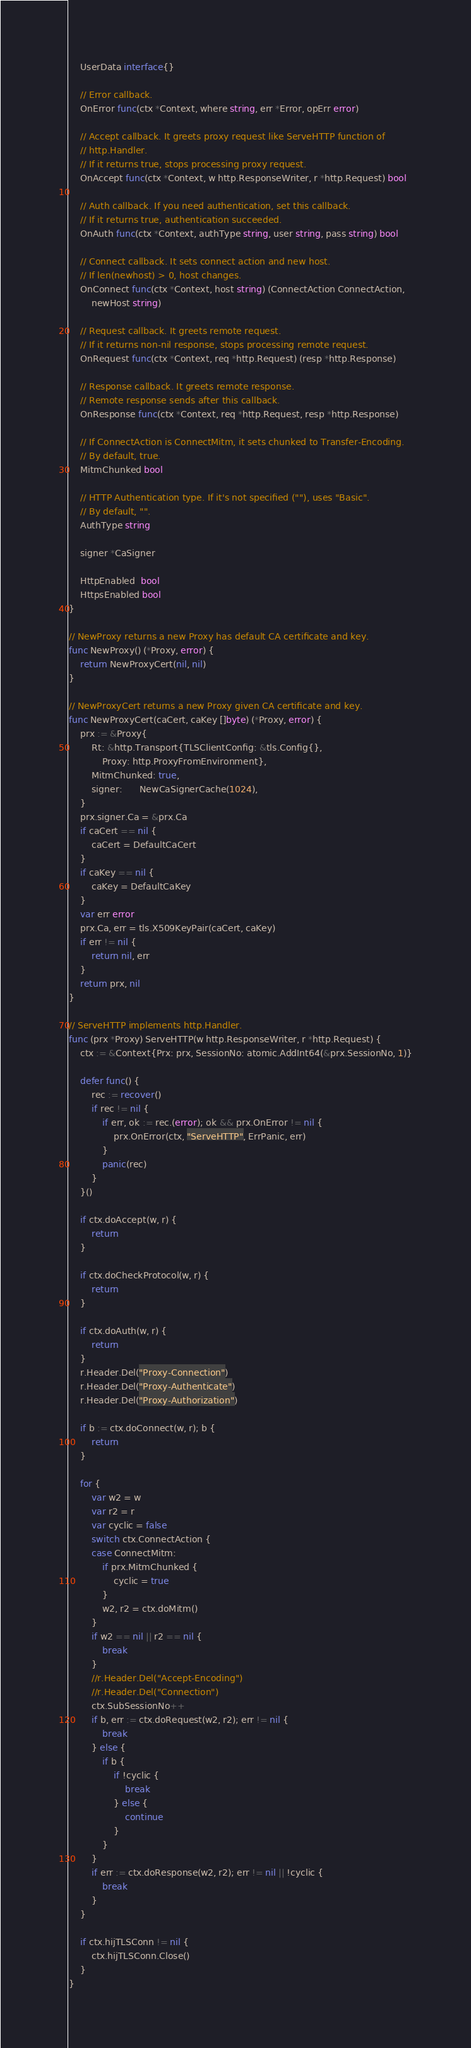<code> <loc_0><loc_0><loc_500><loc_500><_Go_>	UserData interface{}

	// Error callback.
	OnError func(ctx *Context, where string, err *Error, opErr error)

	// Accept callback. It greets proxy request like ServeHTTP function of
	// http.Handler.
	// If it returns true, stops processing proxy request.
	OnAccept func(ctx *Context, w http.ResponseWriter, r *http.Request) bool

	// Auth callback. If you need authentication, set this callback.
	// If it returns true, authentication succeeded.
	OnAuth func(ctx *Context, authType string, user string, pass string) bool

	// Connect callback. It sets connect action and new host.
	// If len(newhost) > 0, host changes.
	OnConnect func(ctx *Context, host string) (ConnectAction ConnectAction,
		newHost string)

	// Request callback. It greets remote request.
	// If it returns non-nil response, stops processing remote request.
	OnRequest func(ctx *Context, req *http.Request) (resp *http.Response)

	// Response callback. It greets remote response.
	// Remote response sends after this callback.
	OnResponse func(ctx *Context, req *http.Request, resp *http.Response)

	// If ConnectAction is ConnectMitm, it sets chunked to Transfer-Encoding.
	// By default, true.
	MitmChunked bool

	// HTTP Authentication type. If it's not specified (""), uses "Basic".
	// By default, "".
	AuthType string

	signer *CaSigner

	HttpEnabled  bool
	HttpsEnabled bool
}

// NewProxy returns a new Proxy has default CA certificate and key.
func NewProxy() (*Proxy, error) {
	return NewProxyCert(nil, nil)
}

// NewProxyCert returns a new Proxy given CA certificate and key.
func NewProxyCert(caCert, caKey []byte) (*Proxy, error) {
	prx := &Proxy{
		Rt: &http.Transport{TLSClientConfig: &tls.Config{},
			Proxy: http.ProxyFromEnvironment},
		MitmChunked: true,
		signer:      NewCaSignerCache(1024),
	}
	prx.signer.Ca = &prx.Ca
	if caCert == nil {
		caCert = DefaultCaCert
	}
	if caKey == nil {
		caKey = DefaultCaKey
	}
	var err error
	prx.Ca, err = tls.X509KeyPair(caCert, caKey)
	if err != nil {
		return nil, err
	}
	return prx, nil
}

// ServeHTTP implements http.Handler.
func (prx *Proxy) ServeHTTP(w http.ResponseWriter, r *http.Request) {
	ctx := &Context{Prx: prx, SessionNo: atomic.AddInt64(&prx.SessionNo, 1)}

	defer func() {
		rec := recover()
		if rec != nil {
			if err, ok := rec.(error); ok && prx.OnError != nil {
				prx.OnError(ctx, "ServeHTTP", ErrPanic, err)
			}
			panic(rec)
		}
	}()

	if ctx.doAccept(w, r) {
		return
	}

	if ctx.doCheckProtocol(w, r) {
		return
	}

	if ctx.doAuth(w, r) {
		return
	}
	r.Header.Del("Proxy-Connection")
	r.Header.Del("Proxy-Authenticate")
	r.Header.Del("Proxy-Authorization")

	if b := ctx.doConnect(w, r); b {
		return
	}

	for {
		var w2 = w
		var r2 = r
		var cyclic = false
		switch ctx.ConnectAction {
		case ConnectMitm:
			if prx.MitmChunked {
				cyclic = true
			}
			w2, r2 = ctx.doMitm()
		}
		if w2 == nil || r2 == nil {
			break
		}
		//r.Header.Del("Accept-Encoding")
		//r.Header.Del("Connection")
		ctx.SubSessionNo++
		if b, err := ctx.doRequest(w2, r2); err != nil {
			break
		} else {
			if b {
				if !cyclic {
					break
				} else {
					continue
				}
			}
		}
		if err := ctx.doResponse(w2, r2); err != nil || !cyclic {
			break
		}
	}

	if ctx.hijTLSConn != nil {
		ctx.hijTLSConn.Close()
	}
}
</code> 